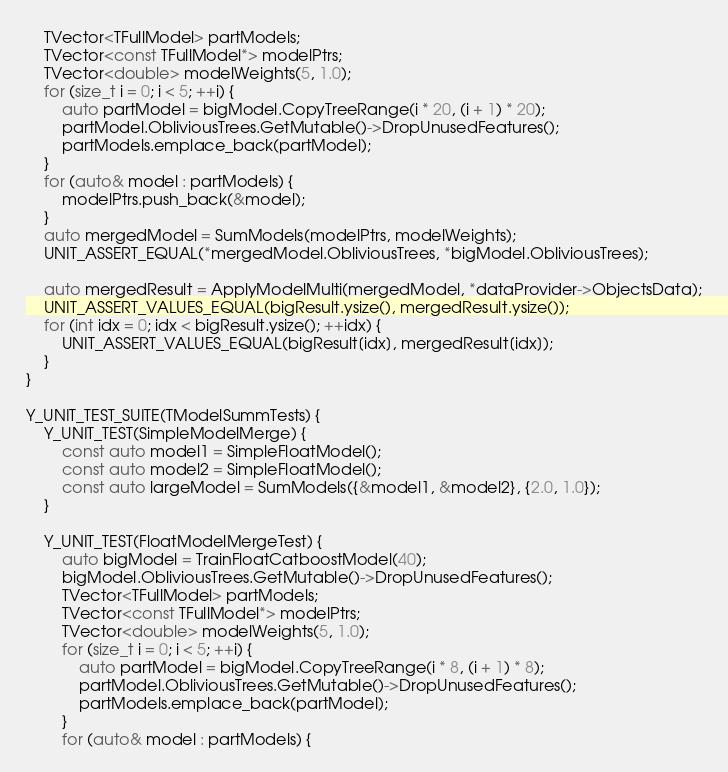Convert code to text. <code><loc_0><loc_0><loc_500><loc_500><_C++_>    TVector<TFullModel> partModels;
    TVector<const TFullModel*> modelPtrs;
    TVector<double> modelWeights(5, 1.0);
    for (size_t i = 0; i < 5; ++i) {
        auto partModel = bigModel.CopyTreeRange(i * 20, (i + 1) * 20);
        partModel.ObliviousTrees.GetMutable()->DropUnusedFeatures();
        partModels.emplace_back(partModel);
    }
    for (auto& model : partModels) {
        modelPtrs.push_back(&model);
    }
    auto mergedModel = SumModels(modelPtrs, modelWeights);
    UNIT_ASSERT_EQUAL(*mergedModel.ObliviousTrees, *bigModel.ObliviousTrees);

    auto mergedResult = ApplyModelMulti(mergedModel, *dataProvider->ObjectsData);
    UNIT_ASSERT_VALUES_EQUAL(bigResult.ysize(), mergedResult.ysize());
    for (int idx = 0; idx < bigResult.ysize(); ++idx) {
        UNIT_ASSERT_VALUES_EQUAL(bigResult[idx], mergedResult[idx]);
    }
}

Y_UNIT_TEST_SUITE(TModelSummTests) {
    Y_UNIT_TEST(SimpleModelMerge) {
        const auto model1 = SimpleFloatModel();
        const auto model2 = SimpleFloatModel();
        const auto largeModel = SumModels({&model1, &model2}, {2.0, 1.0});
    }

    Y_UNIT_TEST(FloatModelMergeTest) {
        auto bigModel = TrainFloatCatboostModel(40);
        bigModel.ObliviousTrees.GetMutable()->DropUnusedFeatures();
        TVector<TFullModel> partModels;
        TVector<const TFullModel*> modelPtrs;
        TVector<double> modelWeights(5, 1.0);
        for (size_t i = 0; i < 5; ++i) {
            auto partModel = bigModel.CopyTreeRange(i * 8, (i + 1) * 8);
            partModel.ObliviousTrees.GetMutable()->DropUnusedFeatures();
            partModels.emplace_back(partModel);
        }
        for (auto& model : partModels) {</code> 